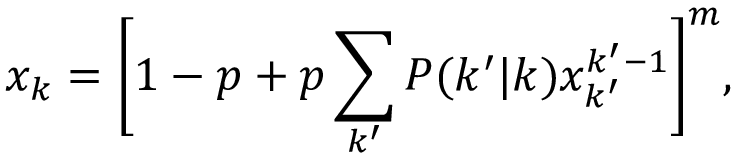Convert formula to latex. <formula><loc_0><loc_0><loc_500><loc_500>x _ { k } = \left [ 1 - p + p \sum _ { k ^ { \prime } } P ( k ^ { \prime } | k ) x _ { k ^ { \prime } } ^ { k ^ { \prime } - 1 } \right ] ^ { m } ,</formula> 